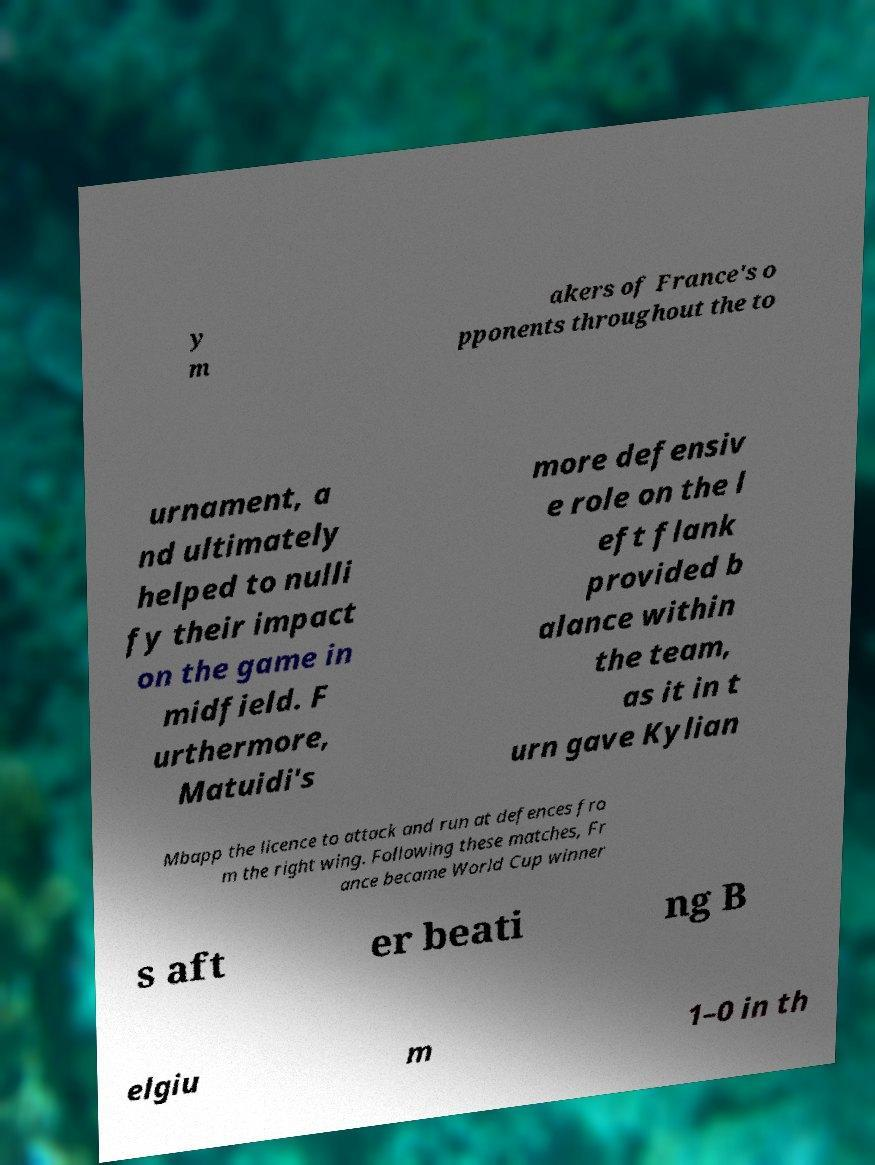Please identify and transcribe the text found in this image. y m akers of France's o pponents throughout the to urnament, a nd ultimately helped to nulli fy their impact on the game in midfield. F urthermore, Matuidi's more defensiv e role on the l eft flank provided b alance within the team, as it in t urn gave Kylian Mbapp the licence to attack and run at defences fro m the right wing. Following these matches, Fr ance became World Cup winner s aft er beati ng B elgiu m 1–0 in th 